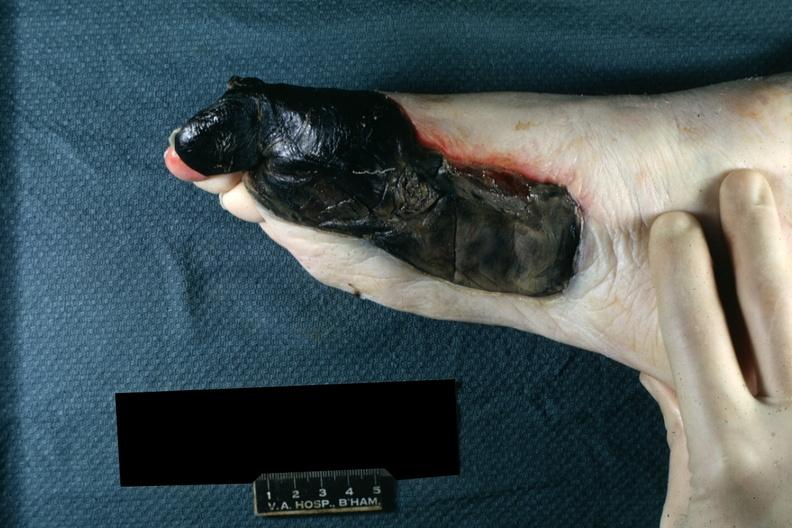re extremities present?
Answer the question using a single word or phrase. Yes 